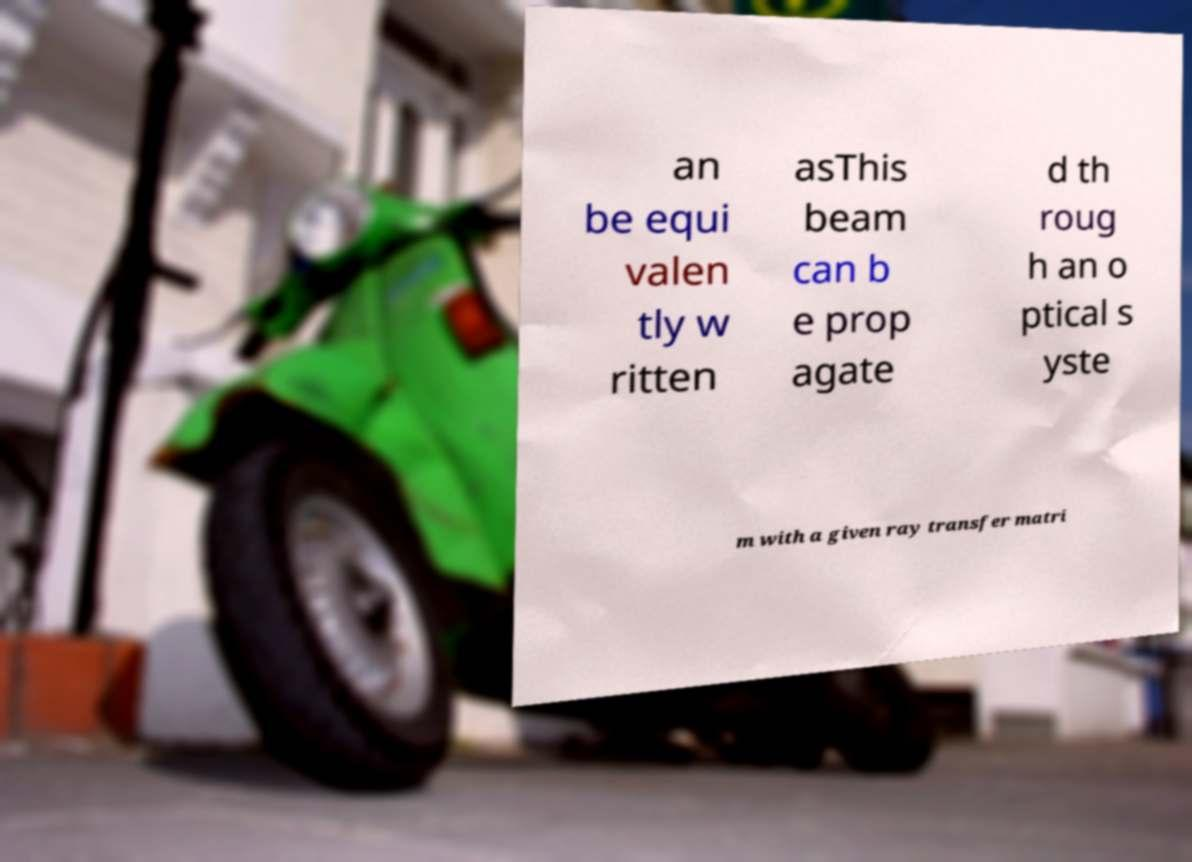Please identify and transcribe the text found in this image. an be equi valen tly w ritten asThis beam can b e prop agate d th roug h an o ptical s yste m with a given ray transfer matri 